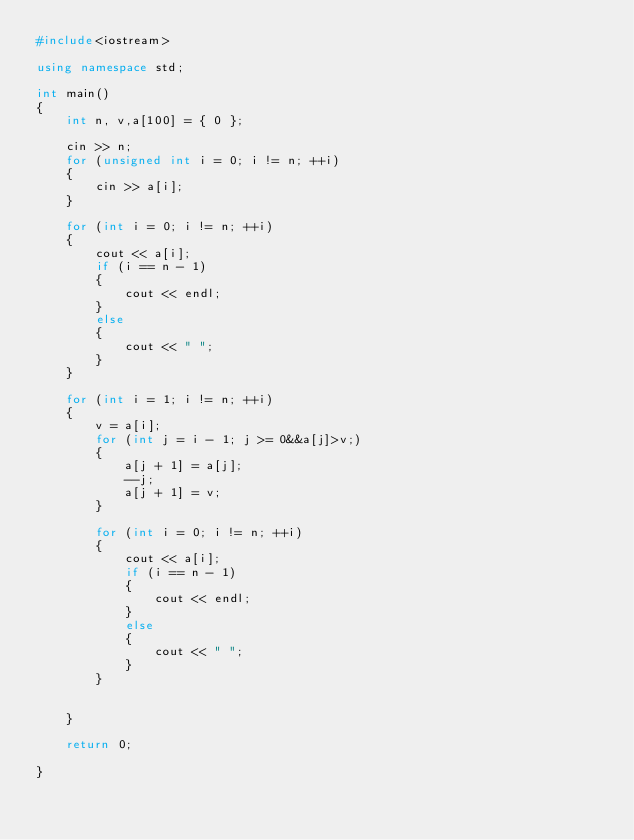<code> <loc_0><loc_0><loc_500><loc_500><_C++_>#include<iostream>

using namespace std;

int main()
{
	int n, v,a[100] = { 0 };

	cin >> n;
	for (unsigned int i = 0; i != n; ++i)
	{
		cin >> a[i];
	}

	for (int i = 0; i != n; ++i)
	{
		cout << a[i];
		if (i == n - 1)
		{
			cout << endl;
		}
		else
		{
			cout << " ";
		}
	}

	for (int i = 1; i != n; ++i)
	{
		v = a[i];
		for (int j = i - 1; j >= 0&&a[j]>v;)
		{
			a[j + 1] = a[j];
			--j;
			a[j + 1] = v;
		}

		for (int i = 0; i != n; ++i)
		{
			cout << a[i];
			if (i == n - 1)
			{
				cout << endl;
			}
			else
			{
				cout << " ";
			}
		}
		
	
	}

	return 0;

}
</code> 